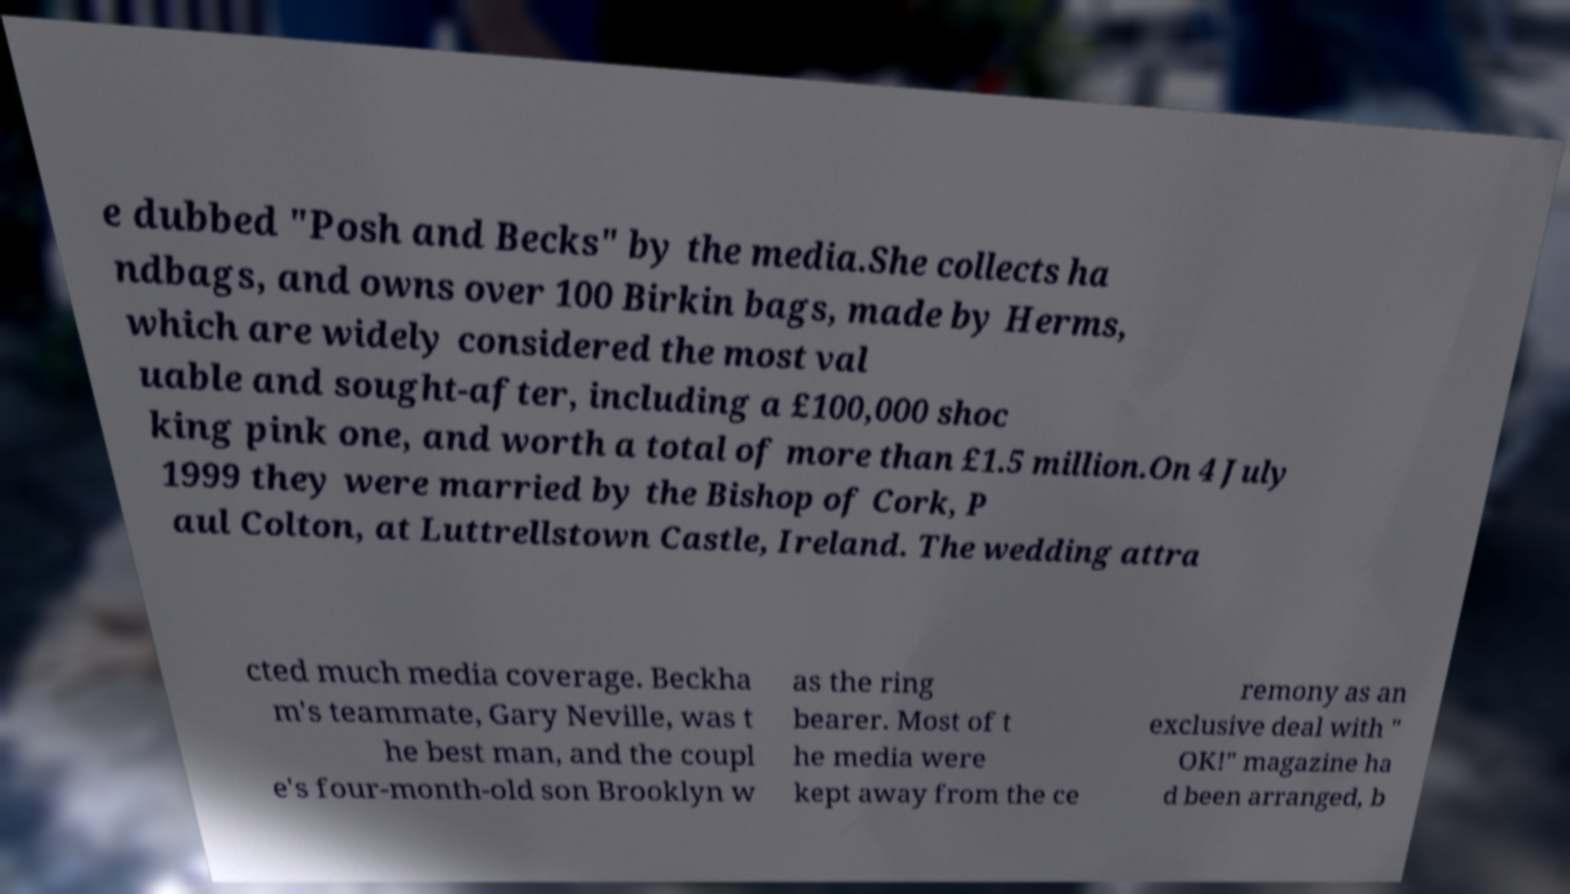Could you extract and type out the text from this image? e dubbed "Posh and Becks" by the media.She collects ha ndbags, and owns over 100 Birkin bags, made by Herms, which are widely considered the most val uable and sought-after, including a £100,000 shoc king pink one, and worth a total of more than £1.5 million.On 4 July 1999 they were married by the Bishop of Cork, P aul Colton, at Luttrellstown Castle, Ireland. The wedding attra cted much media coverage. Beckha m's teammate, Gary Neville, was t he best man, and the coupl e's four-month-old son Brooklyn w as the ring bearer. Most of t he media were kept away from the ce remony as an exclusive deal with " OK!" magazine ha d been arranged, b 